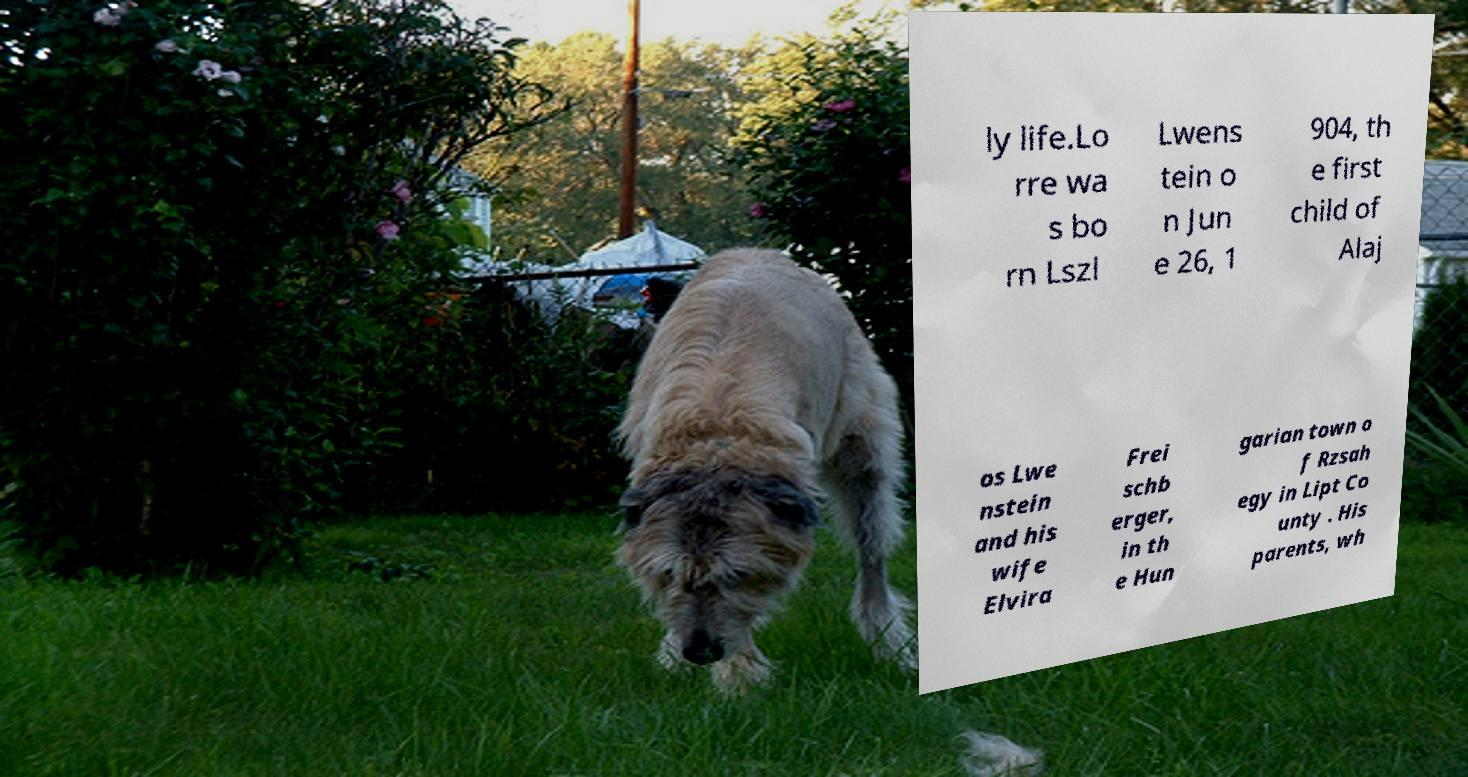Please read and relay the text visible in this image. What does it say? ly life.Lo rre wa s bo rn Lszl Lwens tein o n Jun e 26, 1 904, th e first child of Alaj os Lwe nstein and his wife Elvira Frei schb erger, in th e Hun garian town o f Rzsah egy in Lipt Co unty . His parents, wh 